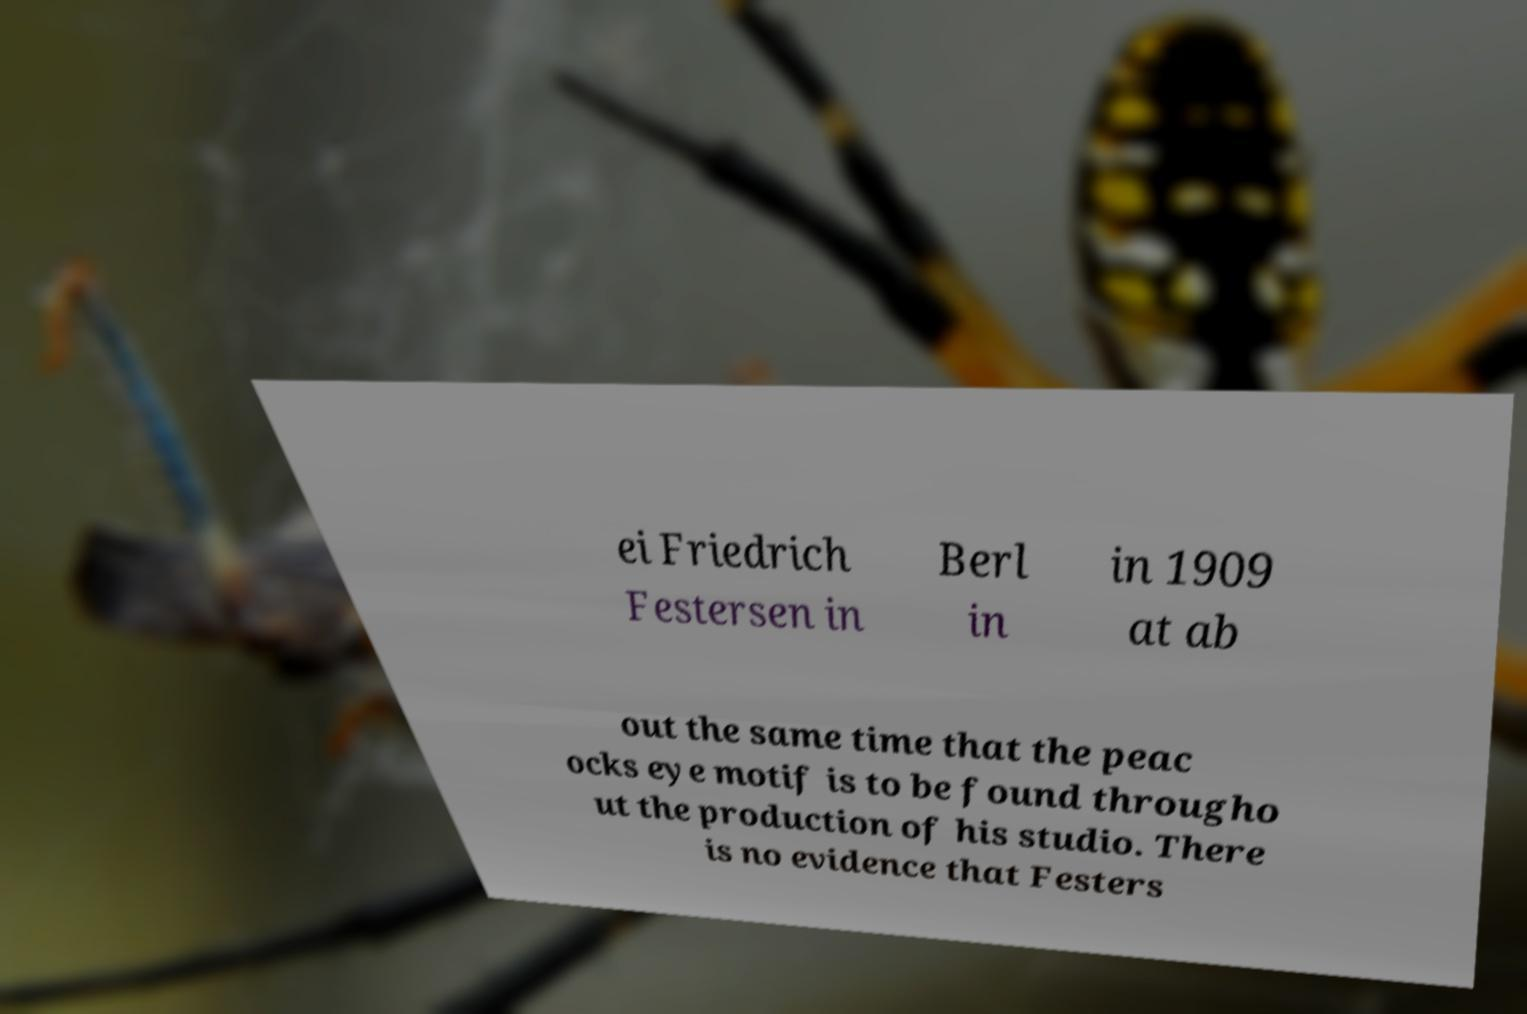What messages or text are displayed in this image? I need them in a readable, typed format. ei Friedrich Festersen in Berl in in 1909 at ab out the same time that the peac ocks eye motif is to be found througho ut the production of his studio. There is no evidence that Festers 